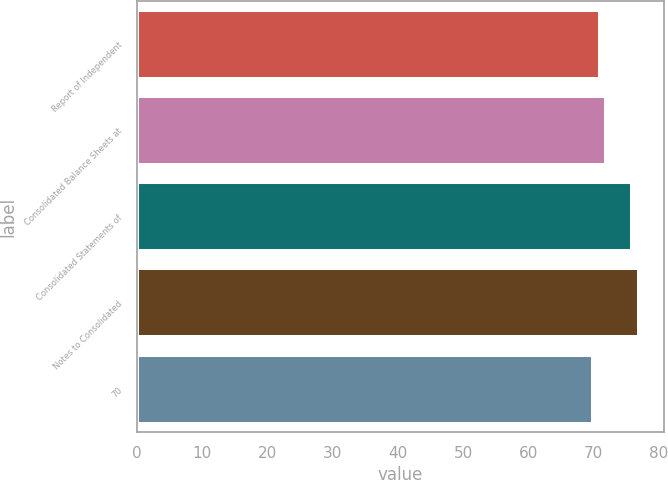Convert chart to OTSL. <chart><loc_0><loc_0><loc_500><loc_500><bar_chart><fcel>Report of Independent<fcel>Consolidated Balance Sheets at<fcel>Consolidated Statements of<fcel>Notes to Consolidated<fcel>70<nl><fcel>71<fcel>72<fcel>76<fcel>77<fcel>70<nl></chart> 